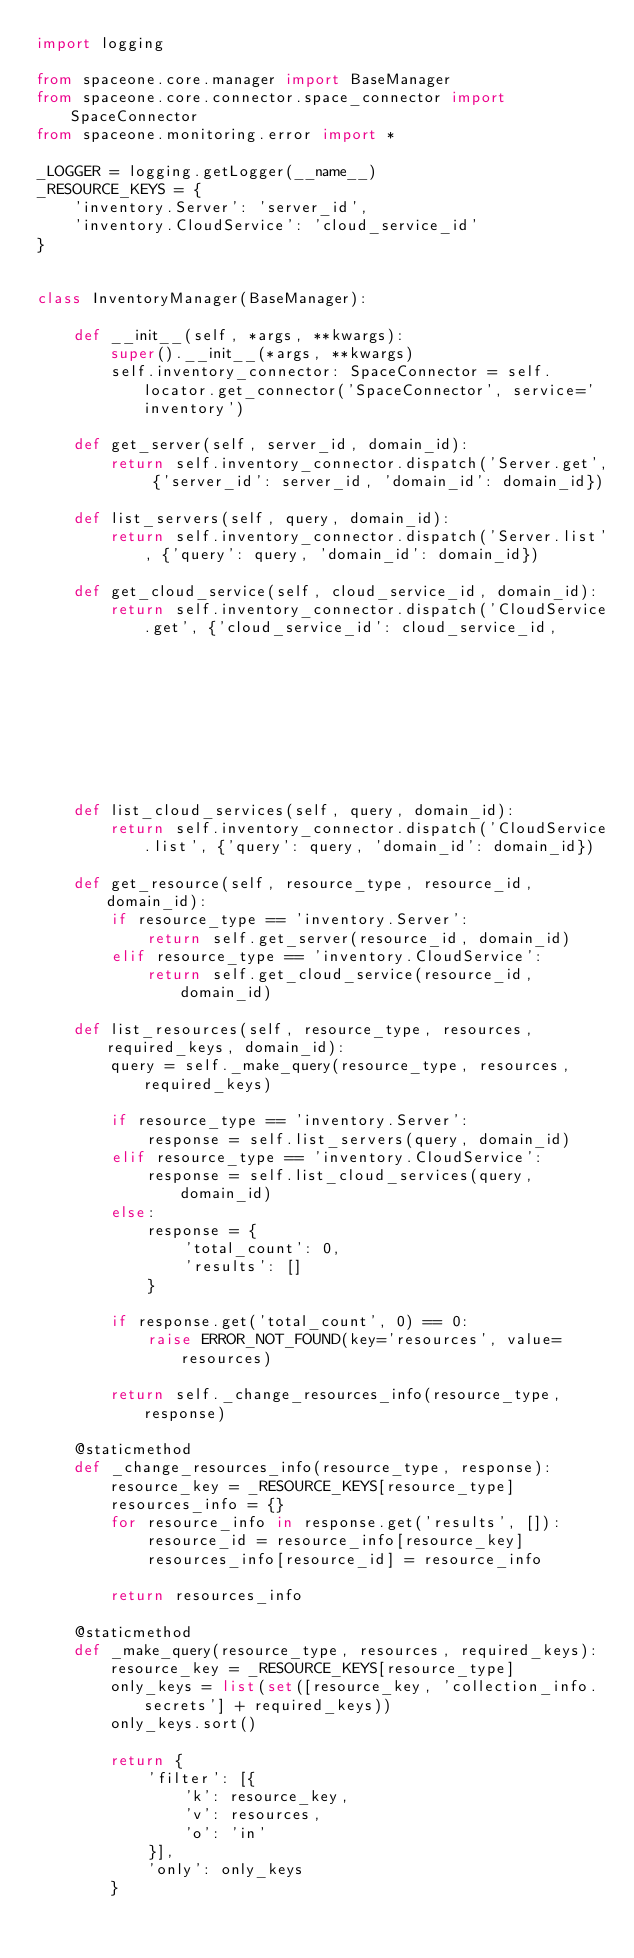Convert code to text. <code><loc_0><loc_0><loc_500><loc_500><_Python_>import logging

from spaceone.core.manager import BaseManager
from spaceone.core.connector.space_connector import SpaceConnector
from spaceone.monitoring.error import *

_LOGGER = logging.getLogger(__name__)
_RESOURCE_KEYS = {
    'inventory.Server': 'server_id',
    'inventory.CloudService': 'cloud_service_id'
}


class InventoryManager(BaseManager):

    def __init__(self, *args, **kwargs):
        super().__init__(*args, **kwargs)
        self.inventory_connector: SpaceConnector = self.locator.get_connector('SpaceConnector', service='inventory')

    def get_server(self, server_id, domain_id):
        return self.inventory_connector.dispatch('Server.get', {'server_id': server_id, 'domain_id': domain_id})

    def list_servers(self, query, domain_id):
        return self.inventory_connector.dispatch('Server.list', {'query': query, 'domain_id': domain_id})

    def get_cloud_service(self, cloud_service_id, domain_id):
        return self.inventory_connector.dispatch('CloudService.get', {'cloud_service_id': cloud_service_id,
                                                                      'domain_id': domain_id})

    def list_cloud_services(self, query, domain_id):
        return self.inventory_connector.dispatch('CloudService.list', {'query': query, 'domain_id': domain_id})

    def get_resource(self, resource_type, resource_id, domain_id):
        if resource_type == 'inventory.Server':
            return self.get_server(resource_id, domain_id)
        elif resource_type == 'inventory.CloudService':
            return self.get_cloud_service(resource_id, domain_id)

    def list_resources(self, resource_type, resources, required_keys, domain_id):
        query = self._make_query(resource_type, resources, required_keys)

        if resource_type == 'inventory.Server':
            response = self.list_servers(query, domain_id)
        elif resource_type == 'inventory.CloudService':
            response = self.list_cloud_services(query, domain_id)
        else:
            response = {
                'total_count': 0,
                'results': []
            }

        if response.get('total_count', 0) == 0:
            raise ERROR_NOT_FOUND(key='resources', value=resources)

        return self._change_resources_info(resource_type, response)

    @staticmethod
    def _change_resources_info(resource_type, response):
        resource_key = _RESOURCE_KEYS[resource_type]
        resources_info = {}
        for resource_info in response.get('results', []):
            resource_id = resource_info[resource_key]
            resources_info[resource_id] = resource_info

        return resources_info

    @staticmethod
    def _make_query(resource_type, resources, required_keys):
        resource_key = _RESOURCE_KEYS[resource_type]
        only_keys = list(set([resource_key, 'collection_info.secrets'] + required_keys))
        only_keys.sort()

        return {
            'filter': [{
                'k': resource_key,
                'v': resources,
                'o': 'in'
            }],
            'only': only_keys
        }
</code> 